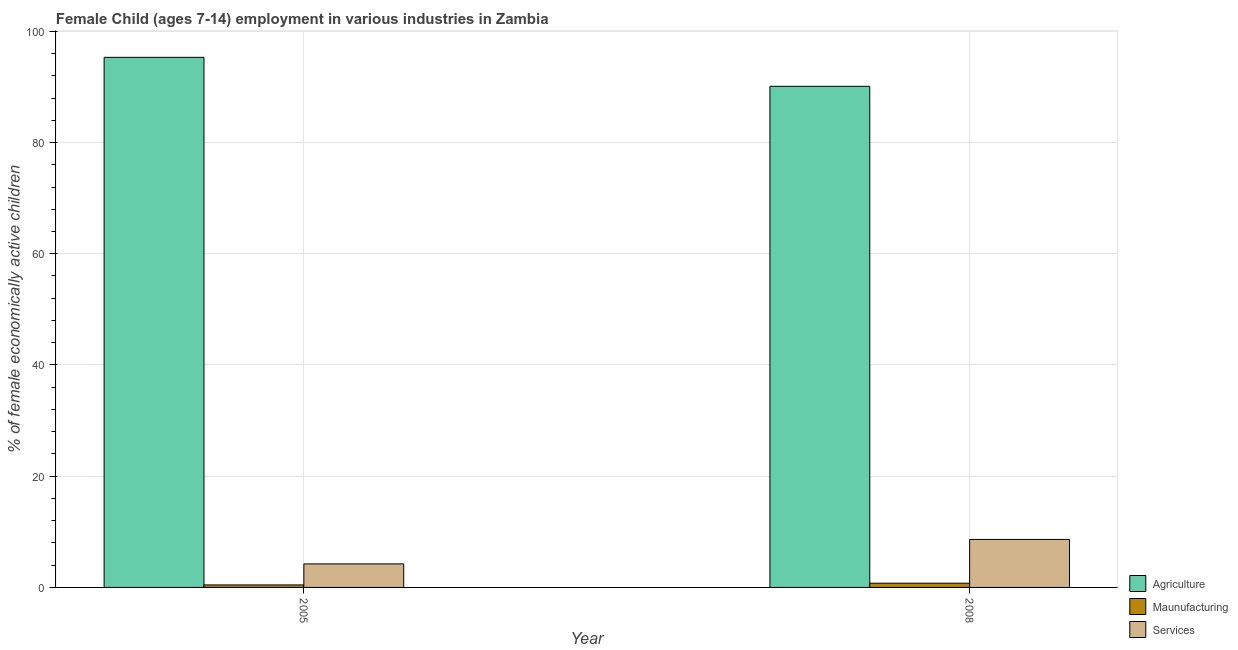How many different coloured bars are there?
Your response must be concise. 3. How many bars are there on the 2nd tick from the left?
Offer a very short reply. 3. How many bars are there on the 1st tick from the right?
Offer a terse response. 3. What is the label of the 1st group of bars from the left?
Make the answer very short. 2005. What is the percentage of economically active children in services in 2008?
Offer a terse response. 8.63. Across all years, what is the maximum percentage of economically active children in manufacturing?
Provide a succinct answer. 0.76. Across all years, what is the minimum percentage of economically active children in services?
Your response must be concise. 4.23. In which year was the percentage of economically active children in manufacturing minimum?
Give a very brief answer. 2005. What is the total percentage of economically active children in manufacturing in the graph?
Provide a succinct answer. 1.21. What is the difference between the percentage of economically active children in services in 2005 and that in 2008?
Offer a very short reply. -4.4. What is the difference between the percentage of economically active children in services in 2008 and the percentage of economically active children in manufacturing in 2005?
Your answer should be compact. 4.4. What is the average percentage of economically active children in manufacturing per year?
Provide a short and direct response. 0.6. In the year 2008, what is the difference between the percentage of economically active children in manufacturing and percentage of economically active children in agriculture?
Ensure brevity in your answer.  0. In how many years, is the percentage of economically active children in manufacturing greater than 24 %?
Ensure brevity in your answer.  0. What is the ratio of the percentage of economically active children in manufacturing in 2005 to that in 2008?
Give a very brief answer. 0.59. What does the 2nd bar from the left in 2008 represents?
Offer a very short reply. Maunufacturing. What does the 3rd bar from the right in 2005 represents?
Provide a succinct answer. Agriculture. How many bars are there?
Offer a terse response. 6. How many years are there in the graph?
Offer a very short reply. 2. What is the difference between two consecutive major ticks on the Y-axis?
Ensure brevity in your answer.  20. Are the values on the major ticks of Y-axis written in scientific E-notation?
Provide a short and direct response. No. Does the graph contain any zero values?
Keep it short and to the point. No. Does the graph contain grids?
Offer a very short reply. Yes. Where does the legend appear in the graph?
Ensure brevity in your answer.  Bottom right. How many legend labels are there?
Your answer should be very brief. 3. How are the legend labels stacked?
Offer a very short reply. Vertical. What is the title of the graph?
Ensure brevity in your answer.  Female Child (ages 7-14) employment in various industries in Zambia. Does "Industrial Nitrous Oxide" appear as one of the legend labels in the graph?
Offer a very short reply. No. What is the label or title of the Y-axis?
Make the answer very short. % of female economically active children. What is the % of female economically active children in Agriculture in 2005?
Ensure brevity in your answer.  95.32. What is the % of female economically active children of Maunufacturing in 2005?
Your answer should be compact. 0.45. What is the % of female economically active children of Services in 2005?
Offer a terse response. 4.23. What is the % of female economically active children in Agriculture in 2008?
Your answer should be very brief. 90.11. What is the % of female economically active children in Maunufacturing in 2008?
Offer a very short reply. 0.76. What is the % of female economically active children of Services in 2008?
Make the answer very short. 8.63. Across all years, what is the maximum % of female economically active children of Agriculture?
Keep it short and to the point. 95.32. Across all years, what is the maximum % of female economically active children of Maunufacturing?
Offer a very short reply. 0.76. Across all years, what is the maximum % of female economically active children in Services?
Offer a very short reply. 8.63. Across all years, what is the minimum % of female economically active children of Agriculture?
Make the answer very short. 90.11. Across all years, what is the minimum % of female economically active children in Maunufacturing?
Provide a short and direct response. 0.45. Across all years, what is the minimum % of female economically active children of Services?
Offer a very short reply. 4.23. What is the total % of female economically active children of Agriculture in the graph?
Make the answer very short. 185.43. What is the total % of female economically active children in Maunufacturing in the graph?
Provide a short and direct response. 1.21. What is the total % of female economically active children in Services in the graph?
Keep it short and to the point. 12.86. What is the difference between the % of female economically active children in Agriculture in 2005 and that in 2008?
Your answer should be compact. 5.21. What is the difference between the % of female economically active children in Maunufacturing in 2005 and that in 2008?
Make the answer very short. -0.31. What is the difference between the % of female economically active children in Services in 2005 and that in 2008?
Your answer should be very brief. -4.4. What is the difference between the % of female economically active children of Agriculture in 2005 and the % of female economically active children of Maunufacturing in 2008?
Give a very brief answer. 94.56. What is the difference between the % of female economically active children in Agriculture in 2005 and the % of female economically active children in Services in 2008?
Your answer should be compact. 86.69. What is the difference between the % of female economically active children of Maunufacturing in 2005 and the % of female economically active children of Services in 2008?
Keep it short and to the point. -8.18. What is the average % of female economically active children of Agriculture per year?
Keep it short and to the point. 92.72. What is the average % of female economically active children of Maunufacturing per year?
Provide a short and direct response. 0.6. What is the average % of female economically active children in Services per year?
Your answer should be very brief. 6.43. In the year 2005, what is the difference between the % of female economically active children in Agriculture and % of female economically active children in Maunufacturing?
Make the answer very short. 94.87. In the year 2005, what is the difference between the % of female economically active children of Agriculture and % of female economically active children of Services?
Provide a succinct answer. 91.09. In the year 2005, what is the difference between the % of female economically active children in Maunufacturing and % of female economically active children in Services?
Give a very brief answer. -3.78. In the year 2008, what is the difference between the % of female economically active children in Agriculture and % of female economically active children in Maunufacturing?
Make the answer very short. 89.35. In the year 2008, what is the difference between the % of female economically active children in Agriculture and % of female economically active children in Services?
Your response must be concise. 81.48. In the year 2008, what is the difference between the % of female economically active children in Maunufacturing and % of female economically active children in Services?
Your answer should be compact. -7.87. What is the ratio of the % of female economically active children in Agriculture in 2005 to that in 2008?
Your answer should be compact. 1.06. What is the ratio of the % of female economically active children of Maunufacturing in 2005 to that in 2008?
Your answer should be compact. 0.59. What is the ratio of the % of female economically active children in Services in 2005 to that in 2008?
Your answer should be compact. 0.49. What is the difference between the highest and the second highest % of female economically active children in Agriculture?
Ensure brevity in your answer.  5.21. What is the difference between the highest and the second highest % of female economically active children in Maunufacturing?
Your answer should be very brief. 0.31. What is the difference between the highest and the lowest % of female economically active children in Agriculture?
Ensure brevity in your answer.  5.21. What is the difference between the highest and the lowest % of female economically active children of Maunufacturing?
Ensure brevity in your answer.  0.31. What is the difference between the highest and the lowest % of female economically active children in Services?
Give a very brief answer. 4.4. 